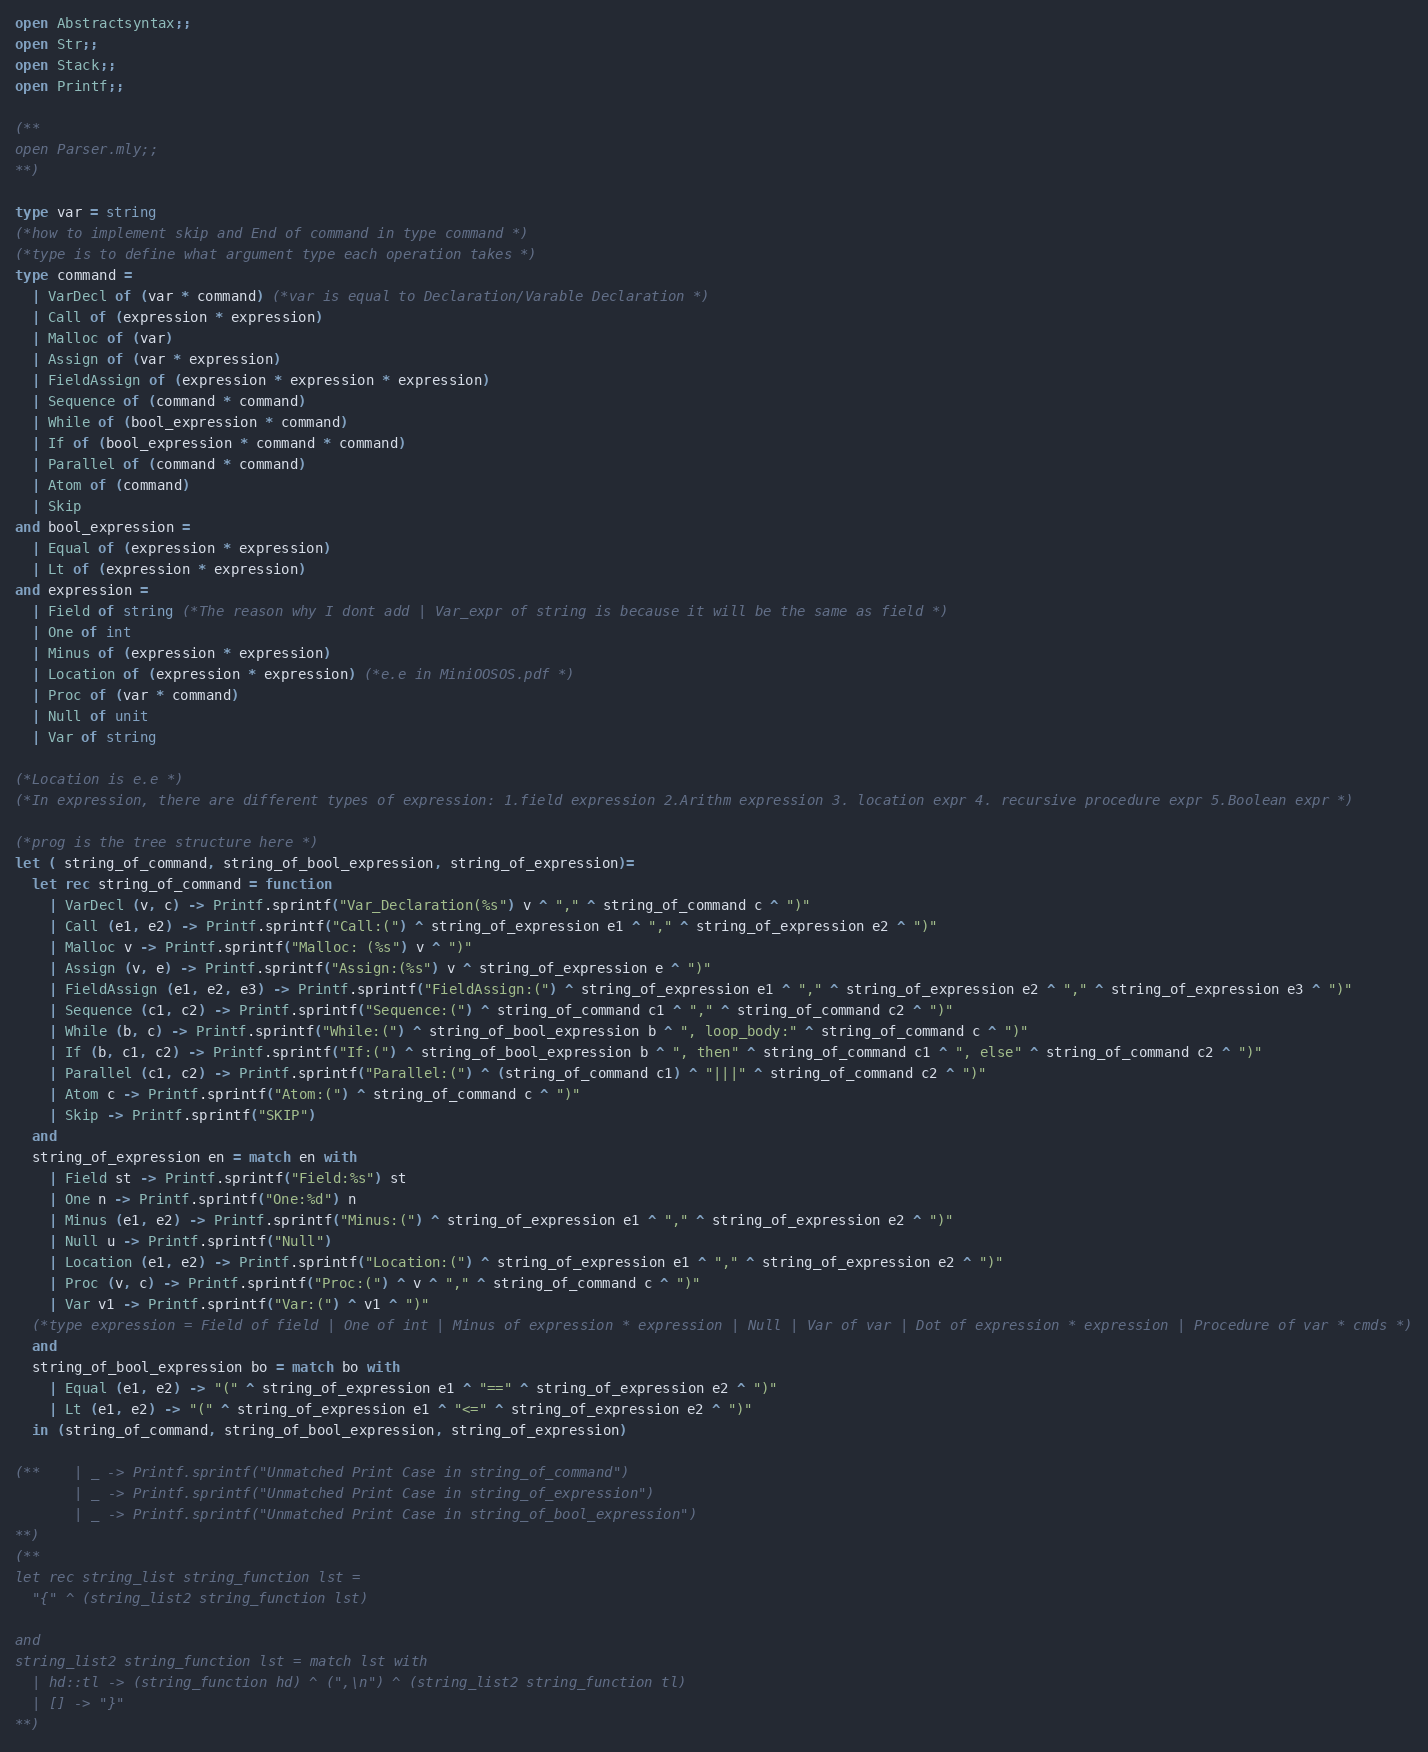<code> <loc_0><loc_0><loc_500><loc_500><_OCaml_>open Abstractsyntax;;
open Str;;
open Stack;;
open Printf;;

(** 
open Parser.mly;;
**)

type var = string 
(*how to implement skip and End of command in type command *)
(*type is to define what argument type each operation takes *)
type command = 
  | VarDecl of (var * command) (*var is equal to Declaration/Varable Declaration *)
  | Call of (expression * expression)
  | Malloc of (var)
  | Assign of (var * expression)
  | FieldAssign of (expression * expression * expression)
  | Sequence of (command * command) 
  | While of (bool_expression * command)
  | If of (bool_expression * command * command)
  | Parallel of (command * command)
  | Atom of (command)
  | Skip
and bool_expression = 
  | Equal of (expression * expression)
  | Lt of (expression * expression)
and expression =
  | Field of string (*The reason why I dont add | Var_expr of string is because it will be the same as field *)
  | One of int
  | Minus of (expression * expression)
  | Location of (expression * expression) (*e.e in MiniOOSOS.pdf *)
  | Proc of (var * command)
  | Null of unit
  | Var of string

(*Location is e.e *)
(*In expression, there are different types of expression: 1.field expression 2.Arithm expression 3. location expr 4. recursive procedure expr 5.Boolean expr *)

(*prog is the tree structure here *)
let ( string_of_command, string_of_bool_expression, string_of_expression)= 
  let rec string_of_command = function
    | VarDecl (v, c) -> Printf.sprintf("Var_Declaration(%s") v ^ "," ^ string_of_command c ^ ")"
    | Call (e1, e2) -> Printf.sprintf("Call:(") ^ string_of_expression e1 ^ "," ^ string_of_expression e2 ^ ")"
    | Malloc v -> Printf.sprintf("Malloc: (%s") v ^ ")"
    | Assign (v, e) -> Printf.sprintf("Assign:(%s") v ^ string_of_expression e ^ ")" 
    | FieldAssign (e1, e2, e3) -> Printf.sprintf("FieldAssign:(") ^ string_of_expression e1 ^ "," ^ string_of_expression e2 ^ "," ^ string_of_expression e3 ^ ")"
    | Sequence (c1, c2) -> Printf.sprintf("Sequence:(") ^ string_of_command c1 ^ "," ^ string_of_command c2 ^ ")"
    | While (b, c) -> Printf.sprintf("While:(") ^ string_of_bool_expression b ^ ", loop_body:" ^ string_of_command c ^ ")"
    | If (b, c1, c2) -> Printf.sprintf("If:(") ^ string_of_bool_expression b ^ ", then" ^ string_of_command c1 ^ ", else" ^ string_of_command c2 ^ ")"
    | Parallel (c1, c2) -> Printf.sprintf("Parallel:(") ^ (string_of_command c1) ^ "|||" ^ string_of_command c2 ^ ")"
    | Atom c -> Printf.sprintf("Atom:(") ^ string_of_command c ^ ")"
    | Skip -> Printf.sprintf("SKIP")
  and 
  string_of_expression en = match en with
    | Field st -> Printf.sprintf("Field:%s") st 
    | One n -> Printf.sprintf("One:%d") n
    | Minus (e1, e2) -> Printf.sprintf("Minus:(") ^ string_of_expression e1 ^ "," ^ string_of_expression e2 ^ ")"
    | Null u -> Printf.sprintf("Null")
    | Location (e1, e2) -> Printf.sprintf("Location:(") ^ string_of_expression e1 ^ "," ^ string_of_expression e2 ^ ")"
    | Proc (v, c) -> Printf.sprintf("Proc:(") ^ v ^ "," ^ string_of_command c ^ ")"
    | Var v1 -> Printf.sprintf("Var:(") ^ v1 ^ ")"
  (*type expression = Field of field | One of int | Minus of expression * expression | Null | Var of var | Dot of expression * expression | Procedure of var * cmds *)
  and 
  string_of_bool_expression bo = match bo with 
    | Equal (e1, e2) -> "(" ^ string_of_expression e1 ^ "==" ^ string_of_expression e2 ^ ")"
    | Lt (e1, e2) -> "(" ^ string_of_expression e1 ^ "<=" ^ string_of_expression e2 ^ ")"
  in (string_of_command, string_of_bool_expression, string_of_expression)

(**    | _ -> Printf.sprintf("Unmatched Print Case in string_of_command")
       | _ -> Printf.sprintf("Unmatched Print Case in string_of_expression")
       | _ -> Printf.sprintf("Unmatched Print Case in string_of_bool_expression")
**)
(** 
let rec string_list string_function lst = 
  "{" ^ (string_list2 string_function lst)

and 
string_list2 string_function lst = match lst with
  | hd::tl -> (string_function hd) ^ (",\n") ^ (string_list2 string_function tl)
  | [] -> "}"
**)</code> 